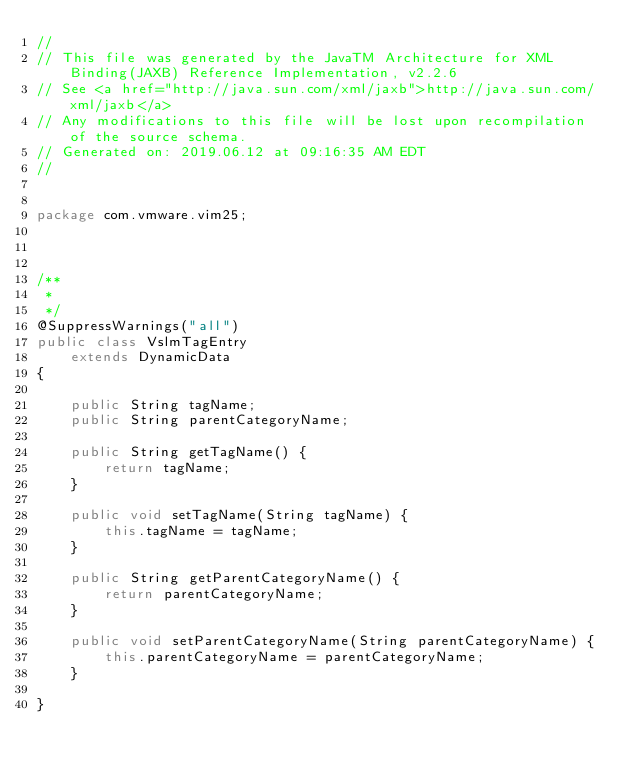<code> <loc_0><loc_0><loc_500><loc_500><_Java_>//
// This file was generated by the JavaTM Architecture for XML Binding(JAXB) Reference Implementation, v2.2.6 
// See <a href="http://java.sun.com/xml/jaxb">http://java.sun.com/xml/jaxb</a> 
// Any modifications to this file will be lost upon recompilation of the source schema. 
// Generated on: 2019.06.12 at 09:16:35 AM EDT 
//


package com.vmware.vim25;



/**
 * 
 */
@SuppressWarnings("all")
public class VslmTagEntry
    extends DynamicData
{

    public String tagName;
    public String parentCategoryName;

    public String getTagName() {
        return tagName;
    }

    public void setTagName(String tagName) {
        this.tagName = tagName;
    }

    public String getParentCategoryName() {
        return parentCategoryName;
    }

    public void setParentCategoryName(String parentCategoryName) {
        this.parentCategoryName = parentCategoryName;
    }

}
</code> 